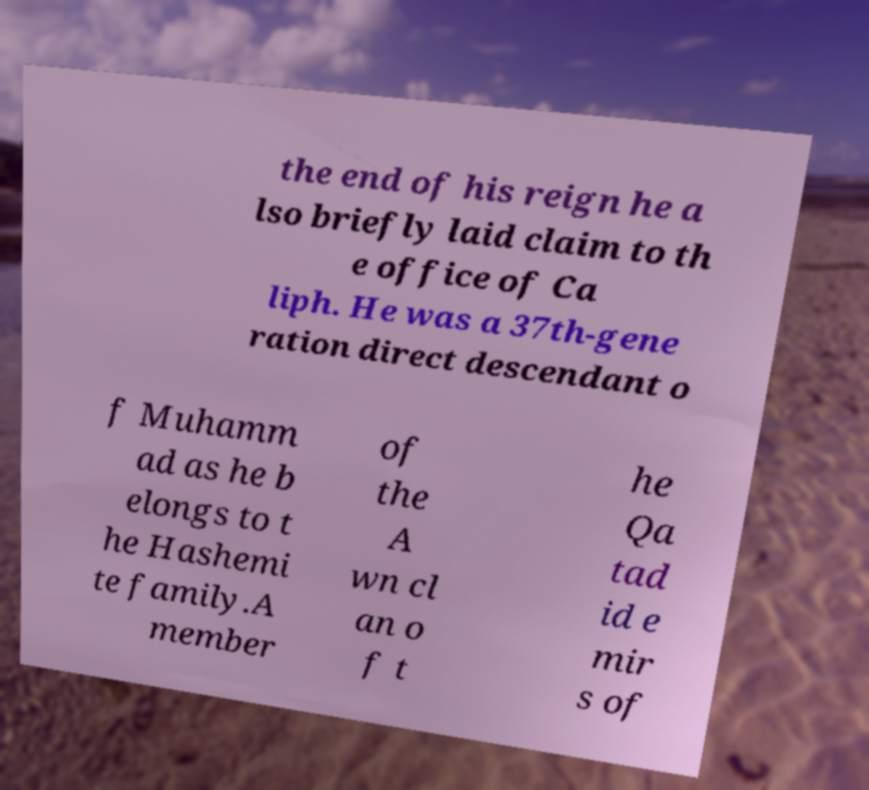There's text embedded in this image that I need extracted. Can you transcribe it verbatim? the end of his reign he a lso briefly laid claim to th e office of Ca liph. He was a 37th-gene ration direct descendant o f Muhamm ad as he b elongs to t he Hashemi te family.A member of the A wn cl an o f t he Qa tad id e mir s of 